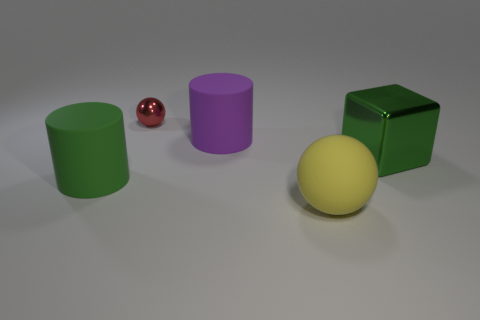Add 3 tiny yellow metal cubes. How many objects exist? 8 Subtract all balls. How many objects are left? 3 Add 2 shiny cubes. How many shiny cubes exist? 3 Subtract 0 blue cubes. How many objects are left? 5 Subtract all rubber cubes. Subtract all small shiny things. How many objects are left? 4 Add 3 big yellow balls. How many big yellow balls are left? 4 